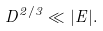<formula> <loc_0><loc_0><loc_500><loc_500>D ^ { 2 / 3 } \ll | E | .</formula> 